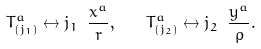<formula> <loc_0><loc_0><loc_500><loc_500>T ^ { a } _ { ( j _ { 1 } ) } \leftrightarrow j _ { 1 } \ \frac { x ^ { a } } { r } , \quad T ^ { a } _ { ( j _ { 2 } ) } \leftrightarrow j _ { 2 } \ \frac { y ^ { a } } { \rho } .</formula> 